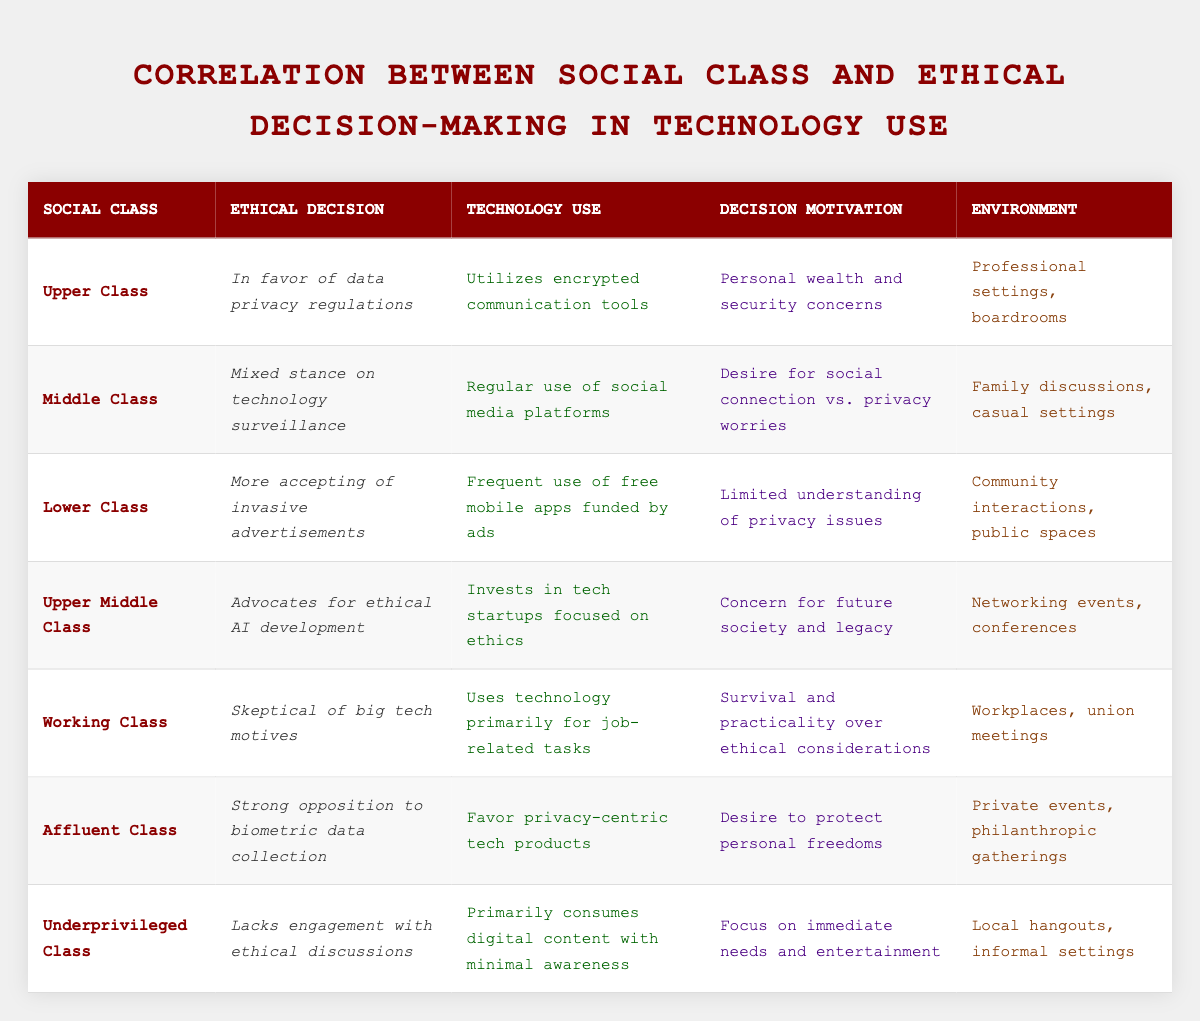What ethical decision does the Lower Class make regarding advertisements? The table shows that the Lower Class makes the ethical decision of being more accepting of invasive advertisements. This can be found in the row where "social_class" is "Lower Class", and under the "ethical_decision" column, it states, "More accepting of invasive advertisements."
Answer: More accepting of invasive advertisements Which social class advocates for ethical AI development? Referring to the table, the "Upper Middle Class" is the social class that advocates for ethical AI development. This is located in the row where "social_class" is "Upper Middle Class" and the corresponding "ethical_decision" states, "Advocates for ethical AI development."
Answer: Upper Middle Class Does the Affluent Class favor biometric data collection? Looking at the table, the Affluent Class is noted for having a strong opposition to biometric data collection, indicating that they do not favor it. Therefore, the answer is "no."
Answer: No What is the decision motivation for the Upper Class regarding technology use? The table indicates that the Upper Class's decision motivation is based on "Personal wealth and security concerns," which is found in the row for the Upper Class under the "decision_motivation" column.
Answer: Personal wealth and security concerns How many social classes support privacy-centric technology products? By examining the table, it is clear that two social classes—Upper Class and Affluent Class—support privacy-centric technology products. These are indicated in their respective rows, where the Upper Class utilizes encrypted communication tools and the Affluent Class favors privacy-centric tech products. Summing these classes gives us a total of two.
Answer: 2 What social class primarily uses technology for job-related tasks? The Working Class is identified in the table as the class that uses technology primarily for job-related tasks. This information is found in the row labeled "Working Class" under the "technology_use" column.
Answer: Working Class What are the environments where the Underprivileged Class engages with technology? According to the table, the Underprivileged Class engages with technology primarily in "Local hangouts, informal settings," which is clearly stated in the row corresponding to the Underprivileged Class under the "environment" column.
Answer: Local hangouts, informal settings Is there any social class that lacks engagement with ethical discussions? The table shows that the Underprivileged Class lacks engagement with ethical discussions, confirming that the statement is true. This can be seen in the row for Underprivileged Class where it states, "Lacks engagement with ethical discussions."
Answer: Yes 